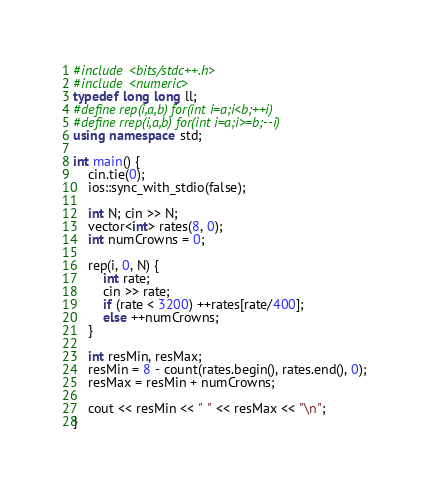<code> <loc_0><loc_0><loc_500><loc_500><_C++_>#include <bits/stdc++.h>
#include <numeric>
typedef long long ll;
#define rep(i,a,b) for(int i=a;i<b;++i)
#define rrep(i,a,b) for(int i=a;i>=b;--i)
using namespace std;

int main() {
    cin.tie(0);
    ios::sync_with_stdio(false);

    int N; cin >> N;
    vector<int> rates(8, 0);
    int numCrowns = 0;

    rep(i, 0, N) {
        int rate;
        cin >> rate;
        if (rate < 3200) ++rates[rate/400];
        else ++numCrowns;
    }

    int resMin, resMax;
    resMin = 8 - count(rates.begin(), rates.end(), 0);
    resMax = resMin + numCrowns;

    cout << resMin << " " << resMax << "\n";
}</code> 